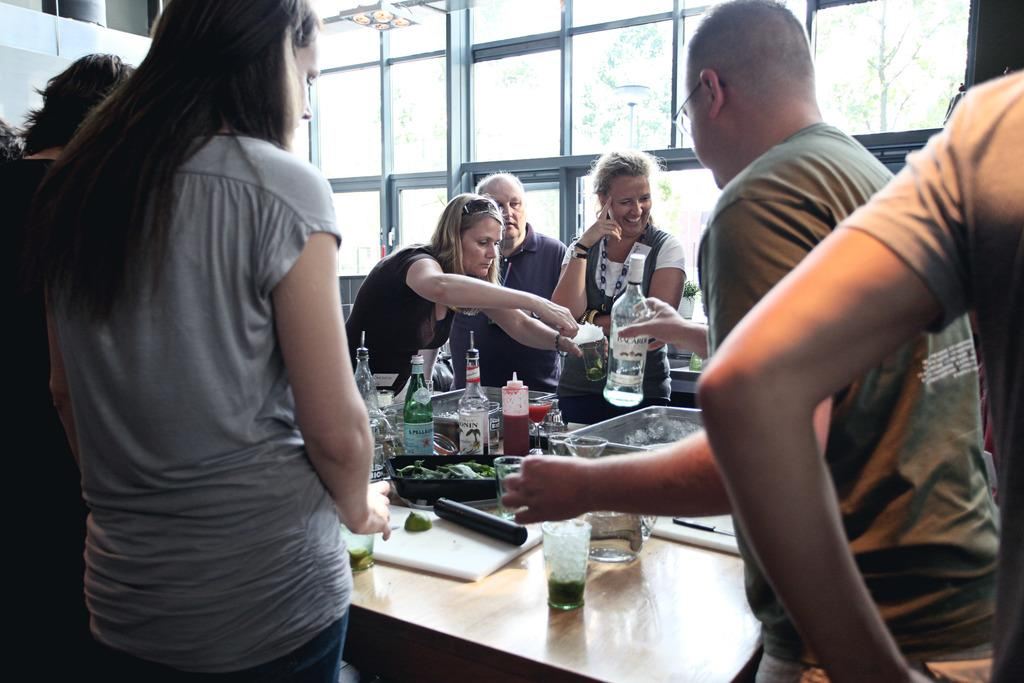How many people are in the group visible in the image? There is a group of people in the image, but the exact number cannot be determined without more specific information. What are the people in the image doing? The people are standing around a table. What can be found on the table in the image? There are eatables and drinks on the table. Can you hear the sound of a whistle in the image? There is no sound present in the image, as it is a static visual representation. What type of cream is being used to prepare the eatables on the table? The image does not provide information about the ingredients or preparation methods of the eatables on the table. 